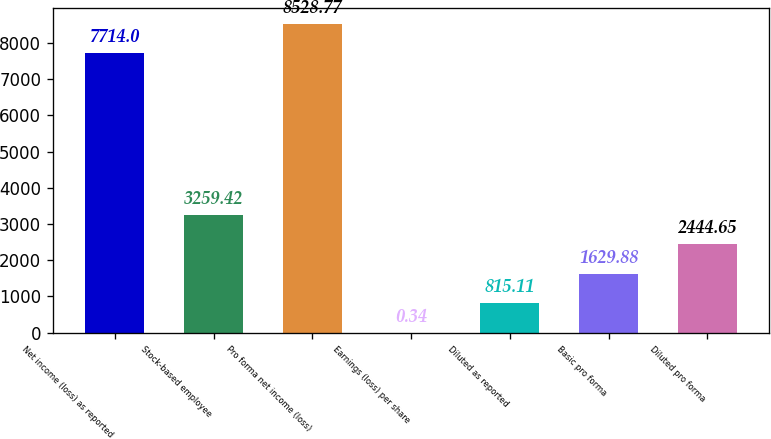Convert chart. <chart><loc_0><loc_0><loc_500><loc_500><bar_chart><fcel>Net income (loss) as reported<fcel>Stock-based employee<fcel>Pro forma net income (loss)<fcel>Earnings (loss) per share<fcel>Diluted as reported<fcel>Basic pro forma<fcel>Diluted pro forma<nl><fcel>7714<fcel>3259.42<fcel>8528.77<fcel>0.34<fcel>815.11<fcel>1629.88<fcel>2444.65<nl></chart> 